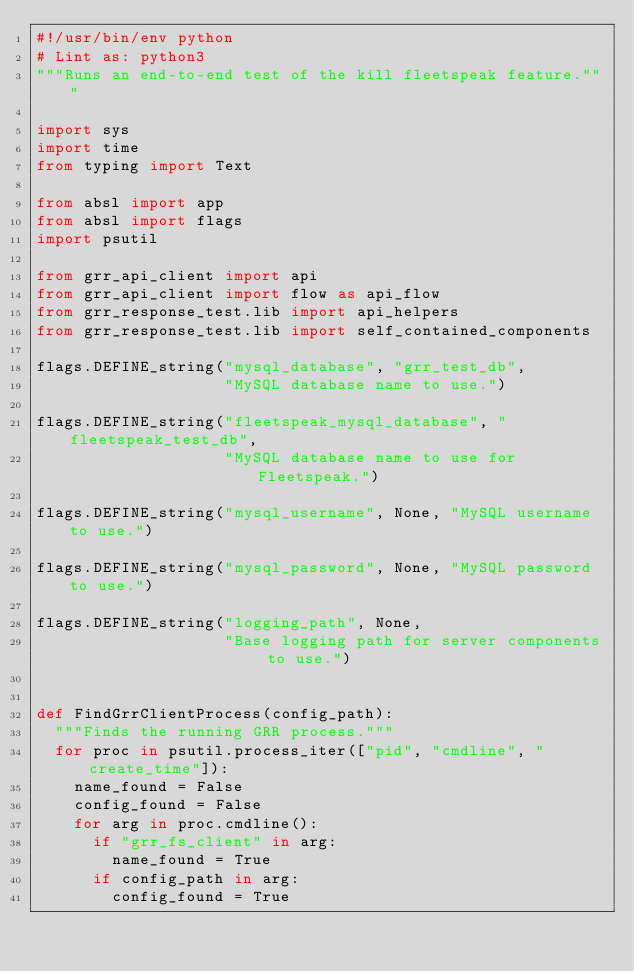Convert code to text. <code><loc_0><loc_0><loc_500><loc_500><_Python_>#!/usr/bin/env python
# Lint as: python3
"""Runs an end-to-end test of the kill fleetspeak feature."""

import sys
import time
from typing import Text

from absl import app
from absl import flags
import psutil

from grr_api_client import api
from grr_api_client import flow as api_flow
from grr_response_test.lib import api_helpers
from grr_response_test.lib import self_contained_components

flags.DEFINE_string("mysql_database", "grr_test_db",
                    "MySQL database name to use.")

flags.DEFINE_string("fleetspeak_mysql_database", "fleetspeak_test_db",
                    "MySQL database name to use for Fleetspeak.")

flags.DEFINE_string("mysql_username", None, "MySQL username to use.")

flags.DEFINE_string("mysql_password", None, "MySQL password to use.")

flags.DEFINE_string("logging_path", None,
                    "Base logging path for server components to use.")


def FindGrrClientProcess(config_path):
  """Finds the running GRR process."""
  for proc in psutil.process_iter(["pid", "cmdline", "create_time"]):
    name_found = False
    config_found = False
    for arg in proc.cmdline():
      if "grr_fs_client" in arg:
        name_found = True
      if config_path in arg:
        config_found = True</code> 